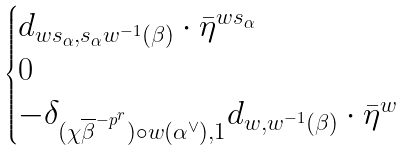Convert formula to latex. <formula><loc_0><loc_0><loc_500><loc_500>\begin{cases} d _ { w s _ { \alpha } , s _ { \alpha } w ^ { - 1 } ( \beta ) } \cdot \bar { \eta } ^ { w s _ { \alpha } } & \\ 0 & \\ - \delta _ { ( \chi \overline { \beta } ^ { - p ^ { r } } ) \circ w ( \alpha ^ { \vee } ) , 1 } d _ { w , w ^ { - 1 } ( \beta ) } \cdot \bar { \eta } ^ { w } & \end{cases}</formula> 